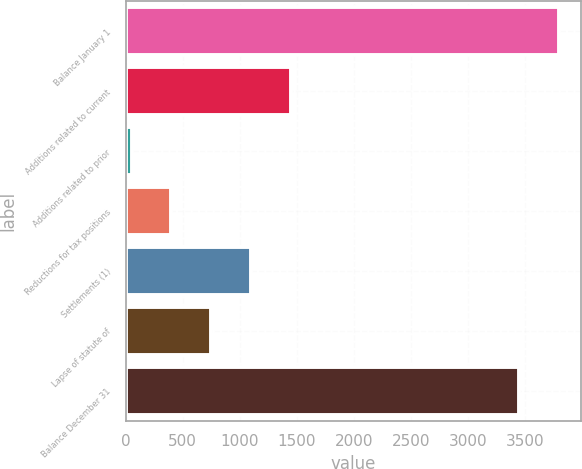<chart> <loc_0><loc_0><loc_500><loc_500><bar_chart><fcel>Balance January 1<fcel>Additions related to current<fcel>Additions related to prior<fcel>Reductions for tax positions<fcel>Settlements (1)<fcel>Lapse of statute of<fcel>Balance December 31<nl><fcel>3796.1<fcel>1445.4<fcel>53<fcel>401.1<fcel>1097.3<fcel>749.2<fcel>3448<nl></chart> 